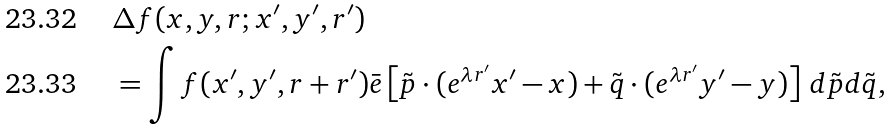Convert formula to latex. <formula><loc_0><loc_0><loc_500><loc_500>& { \Delta } f ( x , y , r ; x ^ { \prime } , y ^ { \prime } , r ^ { \prime } ) \\ & = \int f ( x ^ { \prime } , y ^ { \prime } , r + r ^ { \prime } ) \bar { e } \left [ \tilde { p } \cdot ( e ^ { \lambda r ^ { \prime } } x ^ { \prime } - x ) + \tilde { q } \cdot ( e ^ { \lambda r ^ { \prime } } y ^ { \prime } - y ) \right ] \, d \tilde { p } d \tilde { q } ,</formula> 